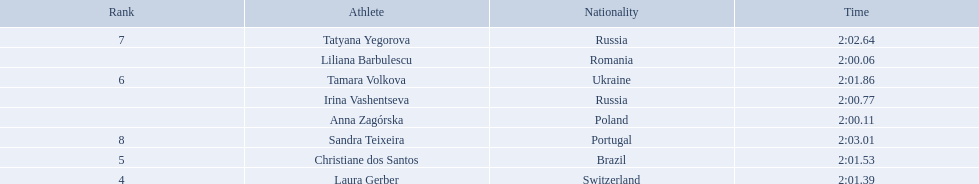Who are all of the athletes? Liliana Barbulescu, Anna Zagórska, Irina Vashentseva, Laura Gerber, Christiane dos Santos, Tamara Volkova, Tatyana Yegorova, Sandra Teixeira. What were their times in the heat? 2:00.06, 2:00.11, 2:00.77, 2:01.39, 2:01.53, 2:01.86, 2:02.64, 2:03.01. Of these, which is the top time? 2:00.06. Which athlete had this time? Liliana Barbulescu. Who were the athlete were in the athletics at the 2003 summer universiade - women's 800 metres? , Liliana Barbulescu, Anna Zagórska, Irina Vashentseva, Laura Gerber, Christiane dos Santos, Tamara Volkova, Tatyana Yegorova, Sandra Teixeira. What was anna zagorska finishing time? 2:00.11. Who came in second place at the athletics at the 2003 summer universiade - women's 800 metres? Anna Zagórska. What was her time? 2:00.11. 